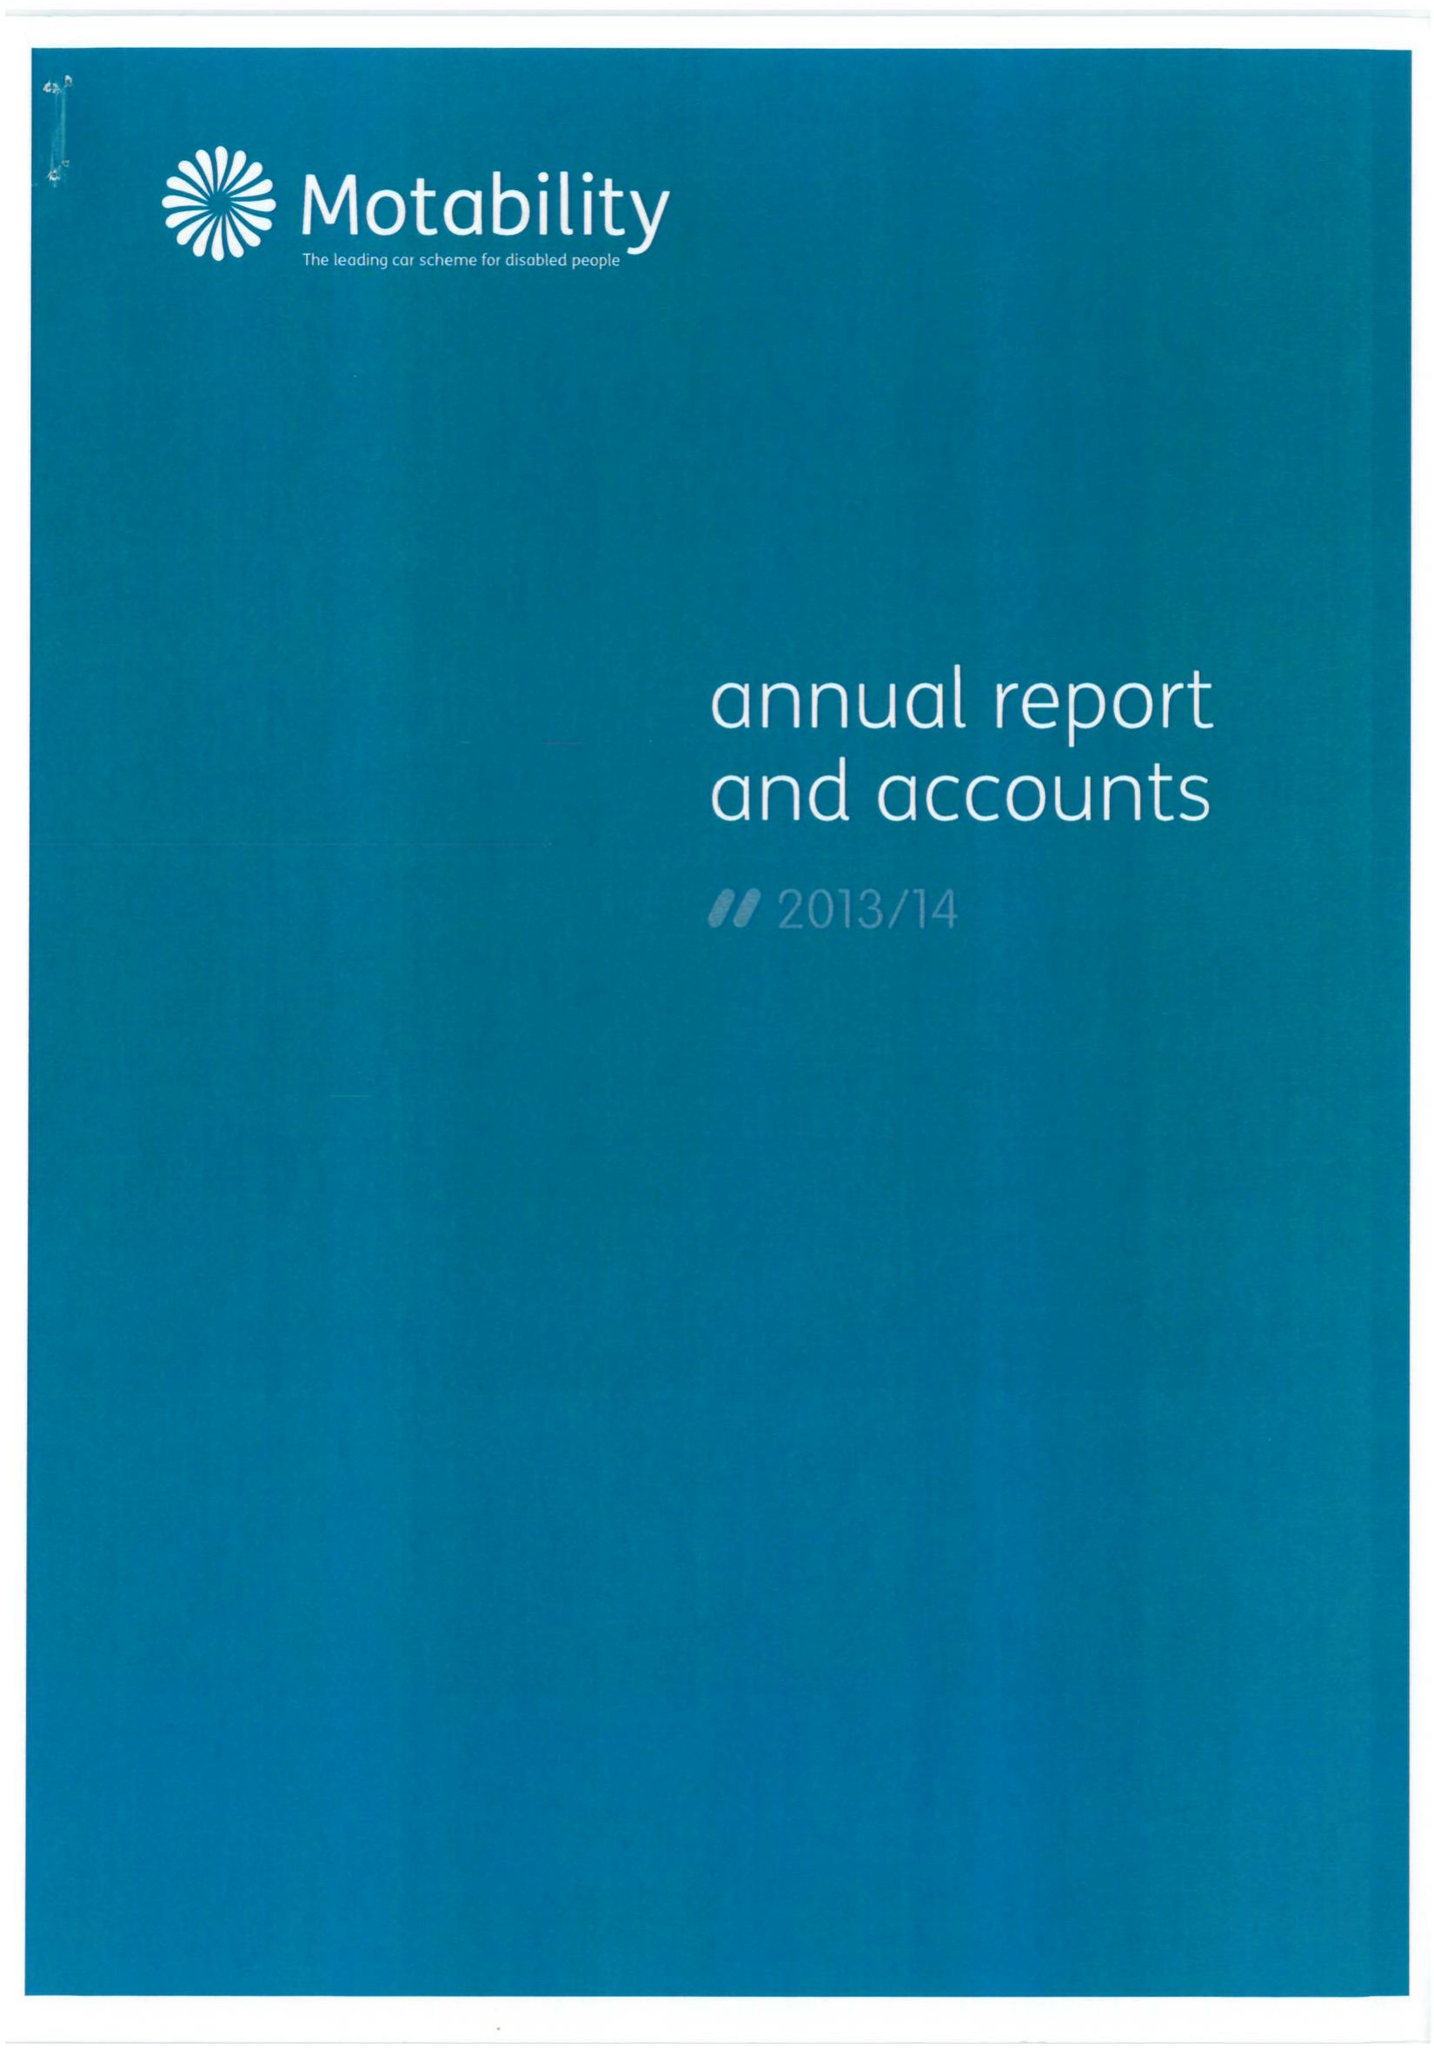What is the value for the spending_annually_in_british_pounds?
Answer the question using a single word or phrase. 28795000.00 